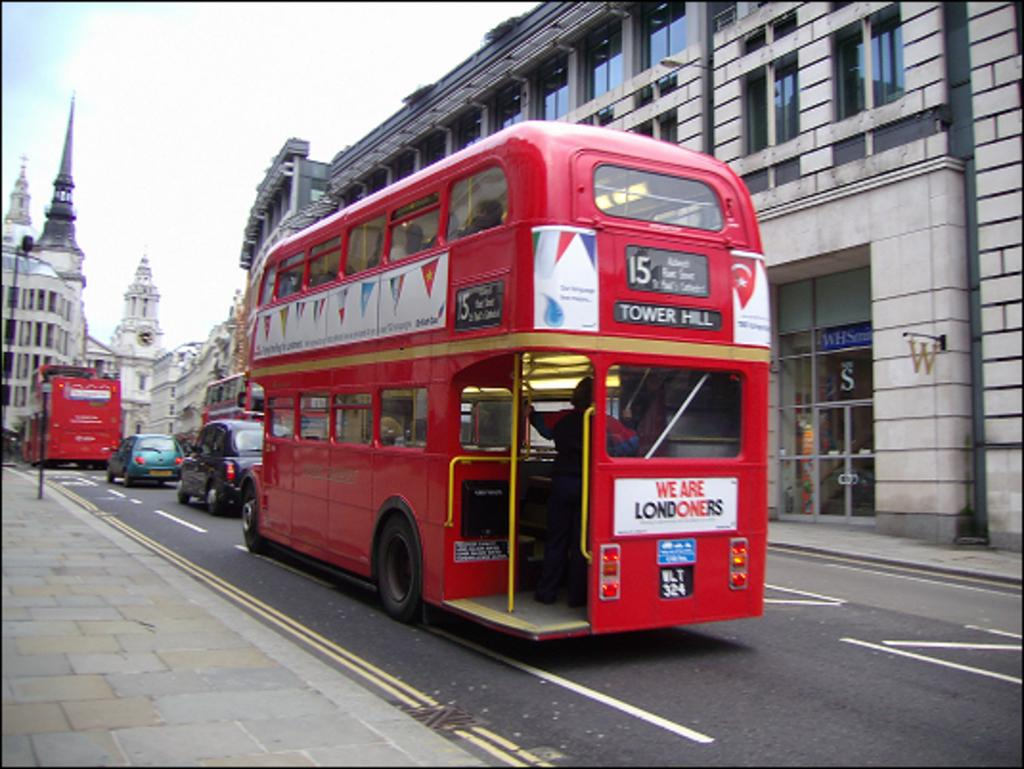<image>
Relay a brief, clear account of the picture shown. A double decker bus in London that is headed towards Tower Hill. 